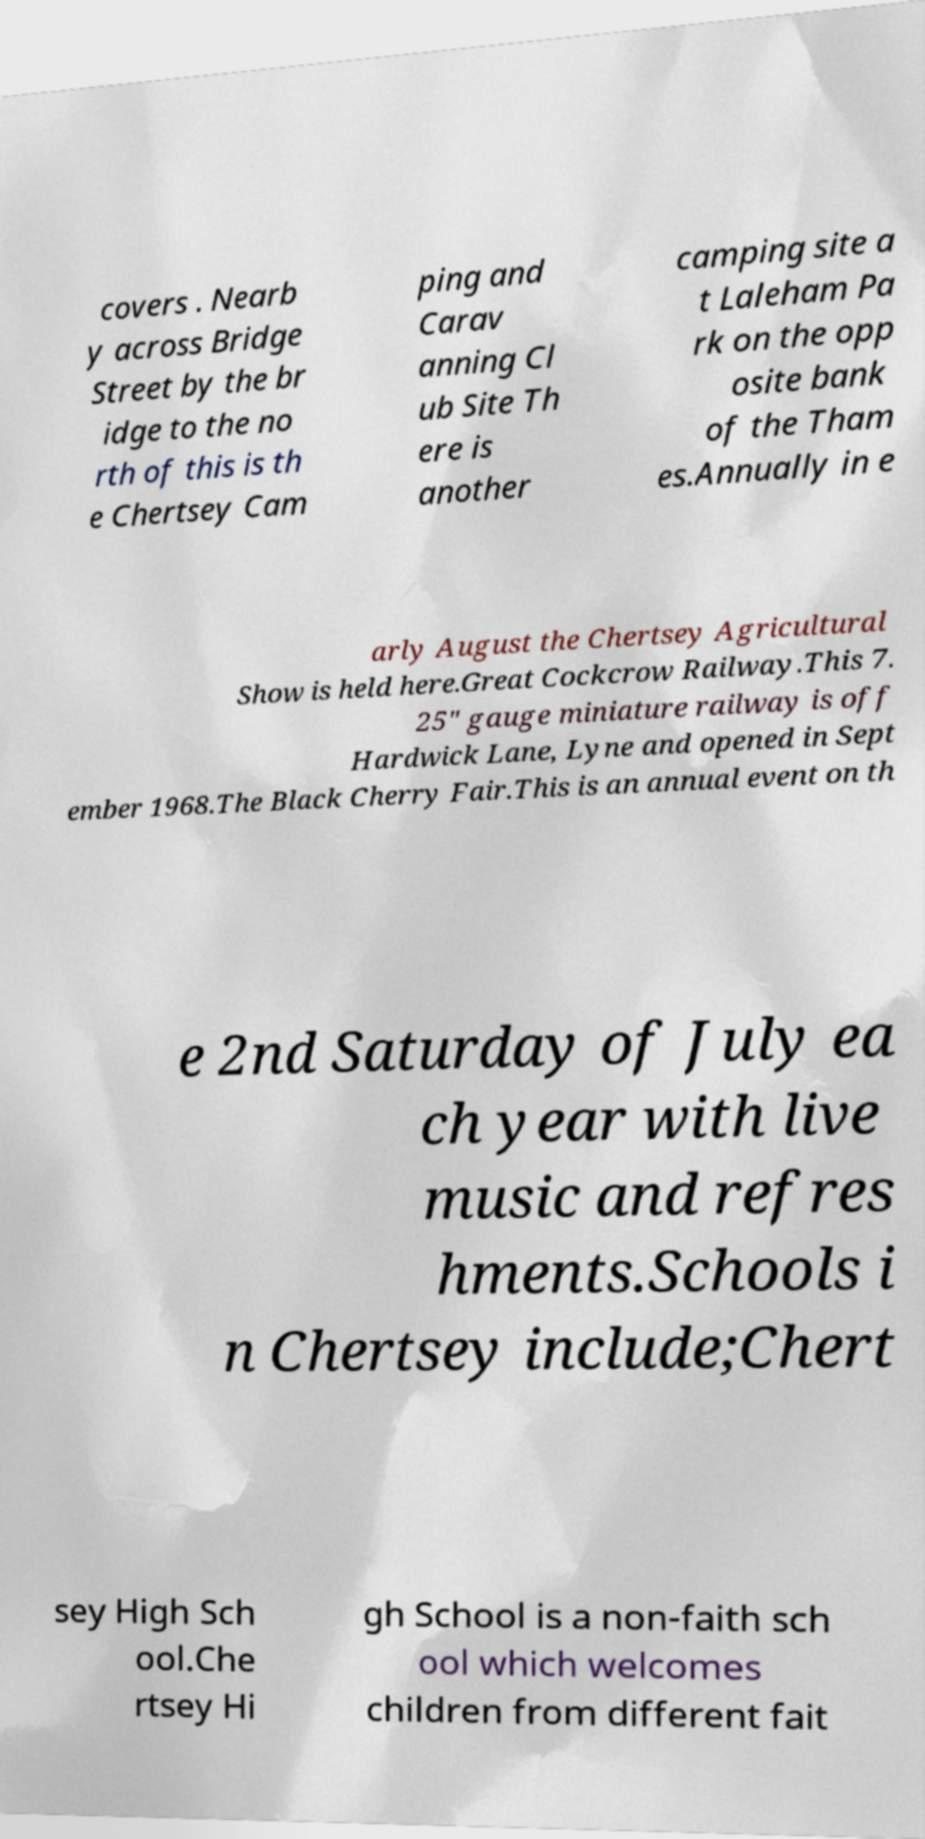Can you read and provide the text displayed in the image?This photo seems to have some interesting text. Can you extract and type it out for me? covers . Nearb y across Bridge Street by the br idge to the no rth of this is th e Chertsey Cam ping and Carav anning Cl ub Site Th ere is another camping site a t Laleham Pa rk on the opp osite bank of the Tham es.Annually in e arly August the Chertsey Agricultural Show is held here.Great Cockcrow Railway.This 7. 25" gauge miniature railway is off Hardwick Lane, Lyne and opened in Sept ember 1968.The Black Cherry Fair.This is an annual event on th e 2nd Saturday of July ea ch year with live music and refres hments.Schools i n Chertsey include;Chert sey High Sch ool.Che rtsey Hi gh School is a non-faith sch ool which welcomes children from different fait 